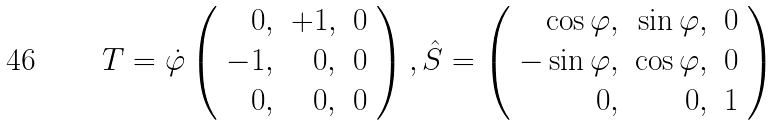<formula> <loc_0><loc_0><loc_500><loc_500>T = \dot { \varphi } \left ( \begin{array} { r r r } 0 , & + 1 , & 0 \\ - 1 , & 0 , & 0 \\ 0 , & 0 , & 0 \end{array} \right ) , \hat { S } = \left ( \begin{array} { r r r } \cos \varphi , & \sin \varphi , & 0 \\ - \sin \varphi , & \cos \varphi , & 0 \\ 0 , & 0 , & 1 \end{array} \right )</formula> 